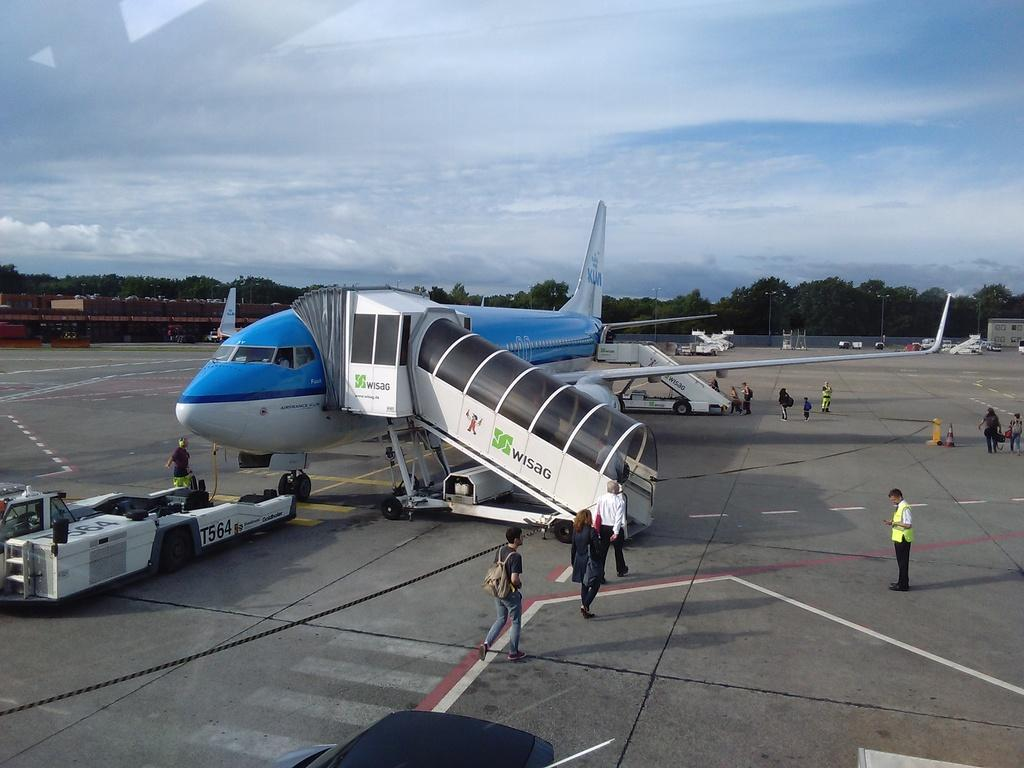Provide a one-sentence caption for the provided image. People are boarding Air France and the officer are patiently waiting for them. 